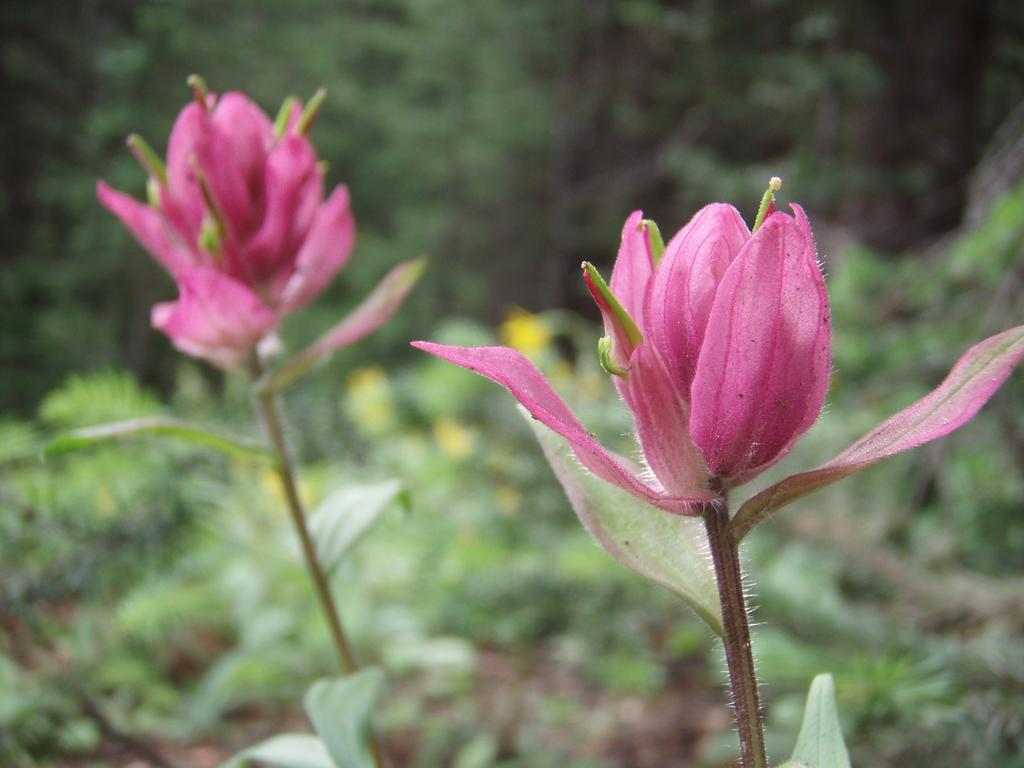What type of living organisms can be seen in the image? Flowers and plants are visible in the image. Can you describe the plants in the image? The plants in the image are not specified, but they are present alongside the flowers. What type of desk can be seen in the image? There is no desk present in the image; it features flowers and plants. Can you tell me how many potatoes are visible in the image? There are no potatoes present in the image; it features flowers and plants. 